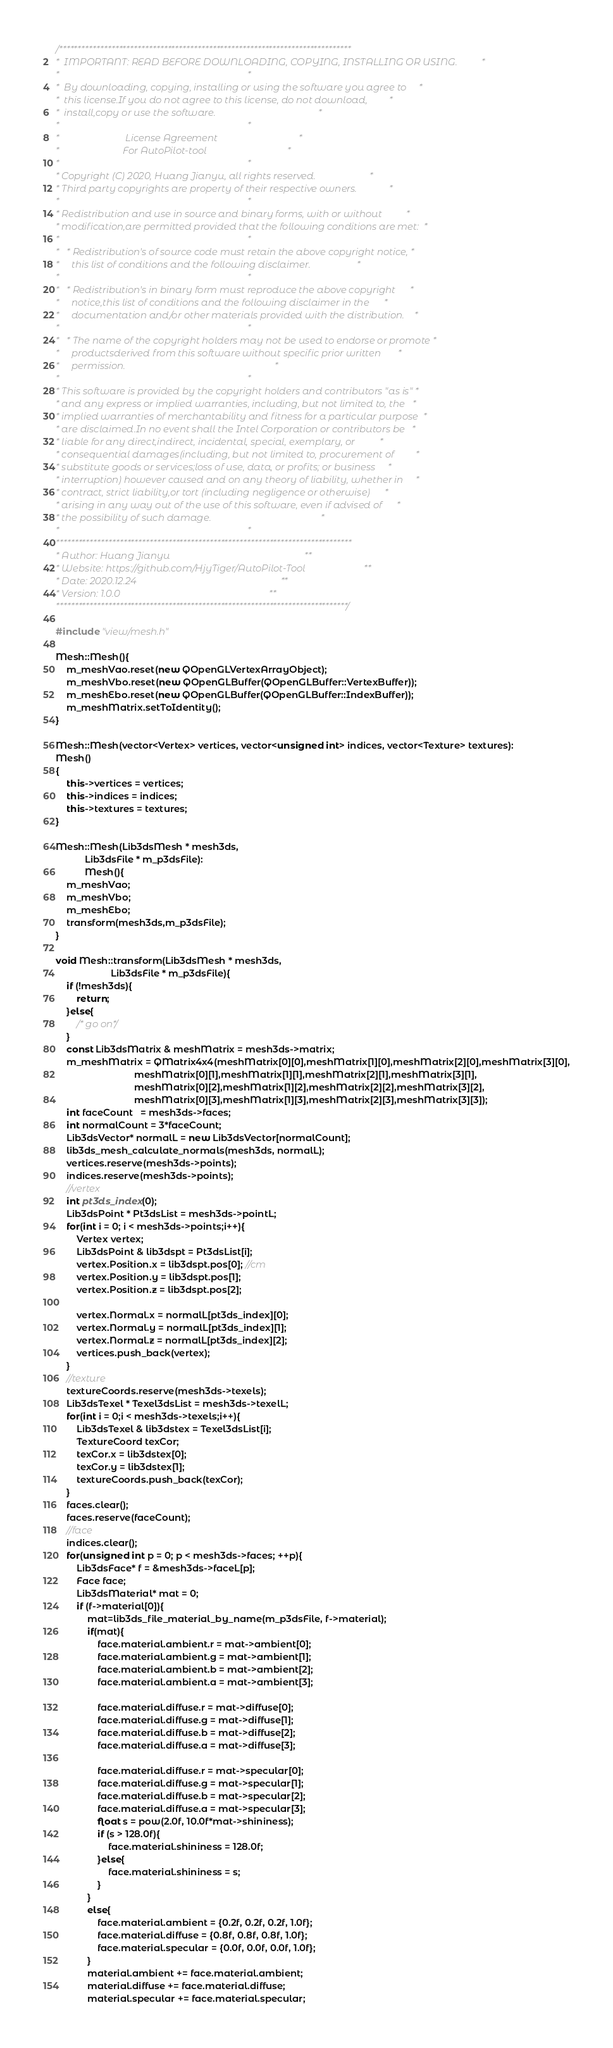Convert code to text. <code><loc_0><loc_0><loc_500><loc_500><_C++_>/******************************************************************************
*  IMPORTANT: READ BEFORE DOWNLOADING, COPYING, INSTALLING OR USING.          *
*                                                                             *
*  By downloading, copying, installing or using the software you agree to     *
*  this license.If you do not agree to this license, do not download,         *
*  install,copy or use the software.                                          *
*                                                                             *
*                           License Agreement                                 *
*                          For AutoPilot-tool                                 *
*                                                                             *
* Copyright (C) 2020, Huang Jianyu, all rights reserved.                      *
* Third party copyrights are property of their respective owners.             *
*                                                                             *
* Redistribution and use in source and binary forms, with or without          *
* modification,are permitted provided that the following conditions are met:  *
*                                                                             *
*   * Redistribution's of source code must retain the above copyright notice, *
*     this list of conditions and the following disclaimer.                   *
*                                                                             *
*   * Redistribution's in binary form must reproduce the above copyright      *
*     notice,this list of conditions and the following disclaimer in the      *
*     documentation and/or other materials provided with the distribution.    *
*                                                                             *
*   * The name of the copyright holders may not be used to endorse or promote *
*     productsderived from this software without specific prior written       *
*     permission.                                                             *
*                                                                             *
* This software is provided by the copyright holders and contributors "as is" *
* and any express or implied warranties, including, but not limited to, the   *
* implied warranties of merchantability and fitness for a particular purpose  *
* are disclaimed.In no event shall the Intel Corporation or contributors be   *
* liable for any direct,indirect, incidental, special, exemplary, or          *
* consequential damages(including, but not limited to, procurement of         *
* substitute goods or services;loss of use, data, or profits; or business     *
* interruption) however caused and on any theory of liability, whether in     *
* contract, strict liability,or tort (including negligence or otherwise)      *
* arising in any way out of the use of this software, even if advised of      *
* the possibility of such damage.                                             *
*                                                                             *
*******************************************************************************
* Author: Huang Jianyu                                                       **
* Website: https://github.com/HjyTiger/AutoPilot-Tool                        **
* Date: 2020.12.24                                                           **
* Version: 1.0.0                                                             **
******************************************************************************/

#include "view/mesh.h"

Mesh::Mesh(){
    m_meshVao.reset(new QOpenGLVertexArrayObject);
    m_meshVbo.reset(new QOpenGLBuffer(QOpenGLBuffer::VertexBuffer));
    m_meshEbo.reset(new QOpenGLBuffer(QOpenGLBuffer::IndexBuffer));   
    m_meshMatrix.setToIdentity();
}

Mesh::Mesh(vector<Vertex> vertices, vector<unsigned int> indices, vector<Texture> textures):
Mesh()
{
    this->vertices = vertices;
    this->indices = indices;
    this->textures = textures;
}

Mesh::Mesh(Lib3dsMesh * mesh3ds,
           Lib3dsFile * m_p3dsFile):
           Mesh(){
    m_meshVao;
    m_meshVbo;
    m_meshEbo;
    transform(mesh3ds,m_p3dsFile);
}

void Mesh::transform(Lib3dsMesh * mesh3ds,
                     Lib3dsFile * m_p3dsFile){
    if (!mesh3ds){
        return;
    }else{
        /* go on*/
    }
    const Lib3dsMatrix & meshMatrix = mesh3ds->matrix;
    m_meshMatrix = QMatrix4x4(meshMatrix[0][0],meshMatrix[1][0],meshMatrix[2][0],meshMatrix[3][0],
                              meshMatrix[0][1],meshMatrix[1][1],meshMatrix[2][1],meshMatrix[3][1],
                              meshMatrix[0][2],meshMatrix[1][2],meshMatrix[2][2],meshMatrix[3][2],
                              meshMatrix[0][3],meshMatrix[1][3],meshMatrix[2][3],meshMatrix[3][3]);
    int faceCount   = mesh3ds->faces;
    int normalCount = 3*faceCount;
    Lib3dsVector* normalL = new Lib3dsVector[normalCount];
    lib3ds_mesh_calculate_normals(mesh3ds, normalL);
    vertices.reserve(mesh3ds->points);
    indices.reserve(mesh3ds->points);
    //vertex
    int pt3ds_index(0);
    Lib3dsPoint * Pt3dsList = mesh3ds->pointL;
    for(int i = 0; i < mesh3ds->points;i++){
        Vertex vertex;
        Lib3dsPoint & lib3dspt = Pt3dsList[i];
        vertex.Position.x = lib3dspt.pos[0]; //cm
        vertex.Position.y = lib3dspt.pos[1];
        vertex.Position.z = lib3dspt.pos[2];

        vertex.Normal.x = normalL[pt3ds_index][0];
        vertex.Normal.y = normalL[pt3ds_index][1];
        vertex.Normal.z = normalL[pt3ds_index][2];
        vertices.push_back(vertex);
    }
    //texture
    textureCoords.reserve(mesh3ds->texels);
    Lib3dsTexel * Texel3dsList = mesh3ds->texelL;
    for(int i = 0;i < mesh3ds->texels;i++){
        Lib3dsTexel & lib3dstex = Texel3dsList[i];
        TextureCoord texCor;
        texCor.x = lib3dstex[0];
        texCor.y = lib3dstex[1];
        textureCoords.push_back(texCor);
    }
    faces.clear();
    faces.reserve(faceCount);
    //face
    indices.clear();
    for(unsigned int p = 0; p < mesh3ds->faces; ++p){
        Lib3dsFace* f = &mesh3ds->faceL[p];
        Face face;
        Lib3dsMaterial* mat = 0;
        if (f->material[0]){
            mat=lib3ds_file_material_by_name(m_p3dsFile, f->material);
            if(mat){
                face.material.ambient.r = mat->ambient[0];
                face.material.ambient.g = mat->ambient[1];
                face.material.ambient.b = mat->ambient[2];
                face.material.ambient.a = mat->ambient[3];

                face.material.diffuse.r = mat->diffuse[0];
                face.material.diffuse.g = mat->diffuse[1];
                face.material.diffuse.b = mat->diffuse[2];
                face.material.diffuse.a = mat->diffuse[3];

                face.material.diffuse.r = mat->specular[0];
                face.material.diffuse.g = mat->specular[1];
                face.material.diffuse.b = mat->specular[2];
                face.material.diffuse.a = mat->specular[3];
                float s = pow(2.0f, 10.0f*mat->shininess);
                if (s > 128.0f){
                    face.material.shininess = 128.0f;
                }else{
                    face.material.shininess = s;
                }
            }
            else{
                face.material.ambient = {0.2f, 0.2f, 0.2f, 1.0f};
                face.material.diffuse = {0.8f, 0.8f, 0.8f, 1.0f};
                face.material.specular = {0.0f, 0.0f, 0.0f, 1.0f};
            }
            material.ambient += face.material.ambient;
            material.diffuse += face.material.diffuse;
            material.specular += face.material.specular;</code> 